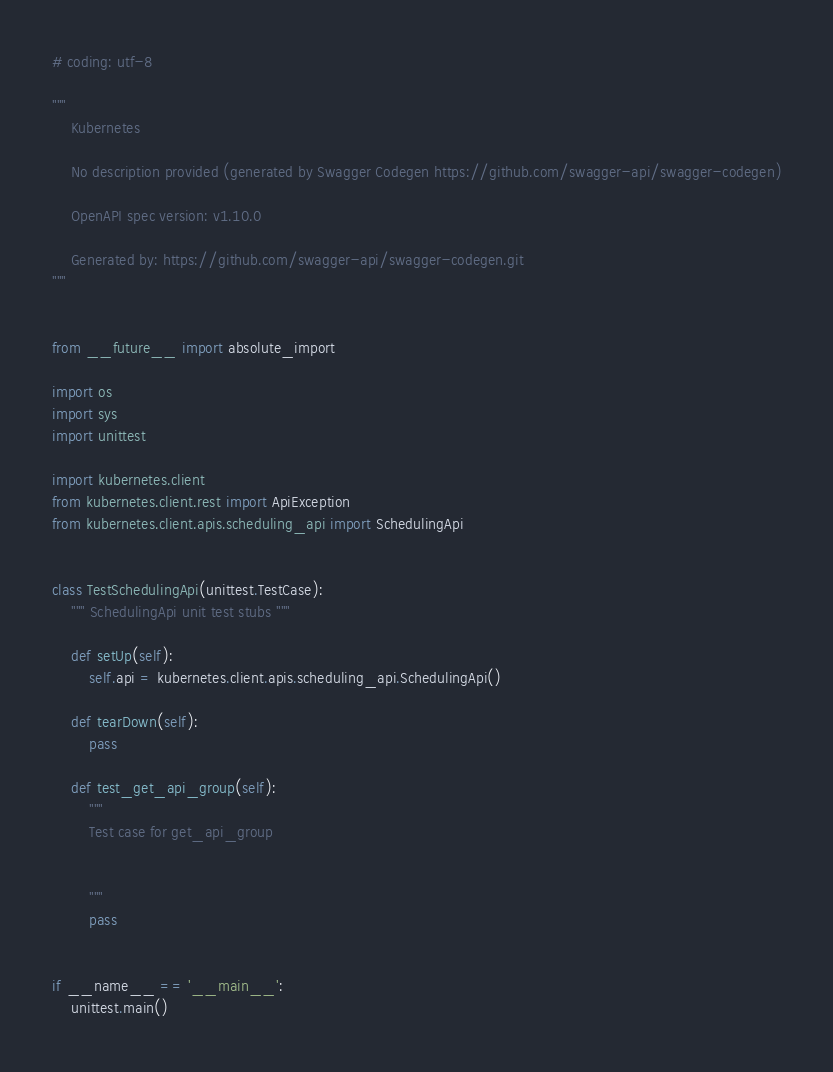Convert code to text. <code><loc_0><loc_0><loc_500><loc_500><_Python_># coding: utf-8

"""
    Kubernetes

    No description provided (generated by Swagger Codegen https://github.com/swagger-api/swagger-codegen)

    OpenAPI spec version: v1.10.0
    
    Generated by: https://github.com/swagger-api/swagger-codegen.git
"""


from __future__ import absolute_import

import os
import sys
import unittest

import kubernetes.client
from kubernetes.client.rest import ApiException
from kubernetes.client.apis.scheduling_api import SchedulingApi


class TestSchedulingApi(unittest.TestCase):
    """ SchedulingApi unit test stubs """

    def setUp(self):
        self.api = kubernetes.client.apis.scheduling_api.SchedulingApi()

    def tearDown(self):
        pass

    def test_get_api_group(self):
        """
        Test case for get_api_group

        
        """
        pass


if __name__ == '__main__':
    unittest.main()
</code> 